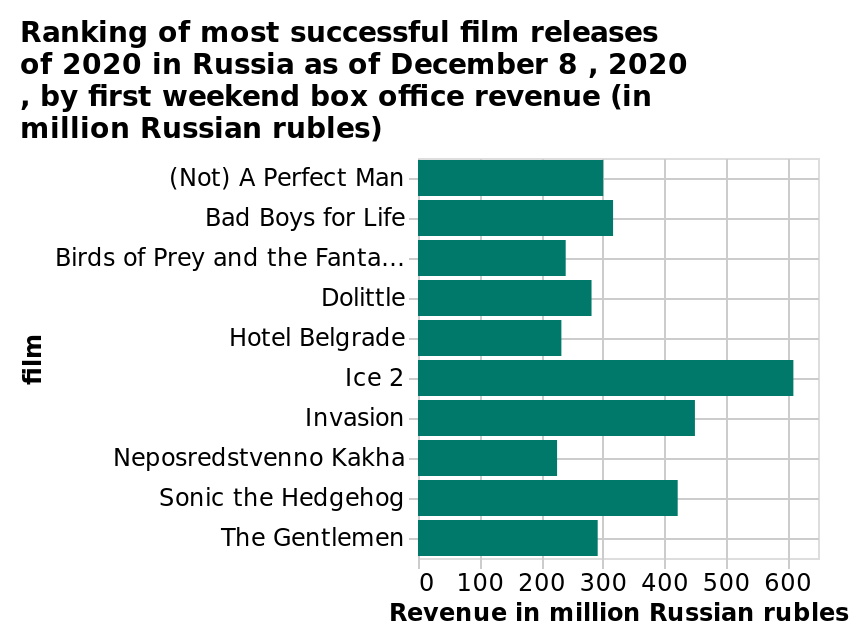<image>
Which film had the highest box office earnings in 2020?  Ice 2. 